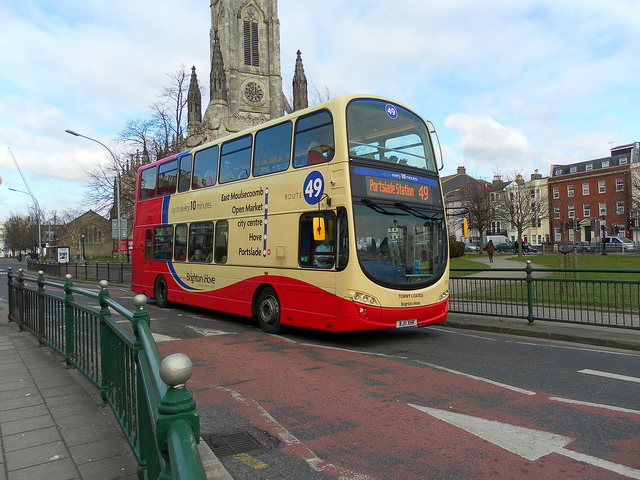<image>Is that bus going to leave soon? I don't know if the bus is going to leave soon. Is that bus going to leave soon? I am not sure if the bus is going to leave soon. It can be both yes or no. 